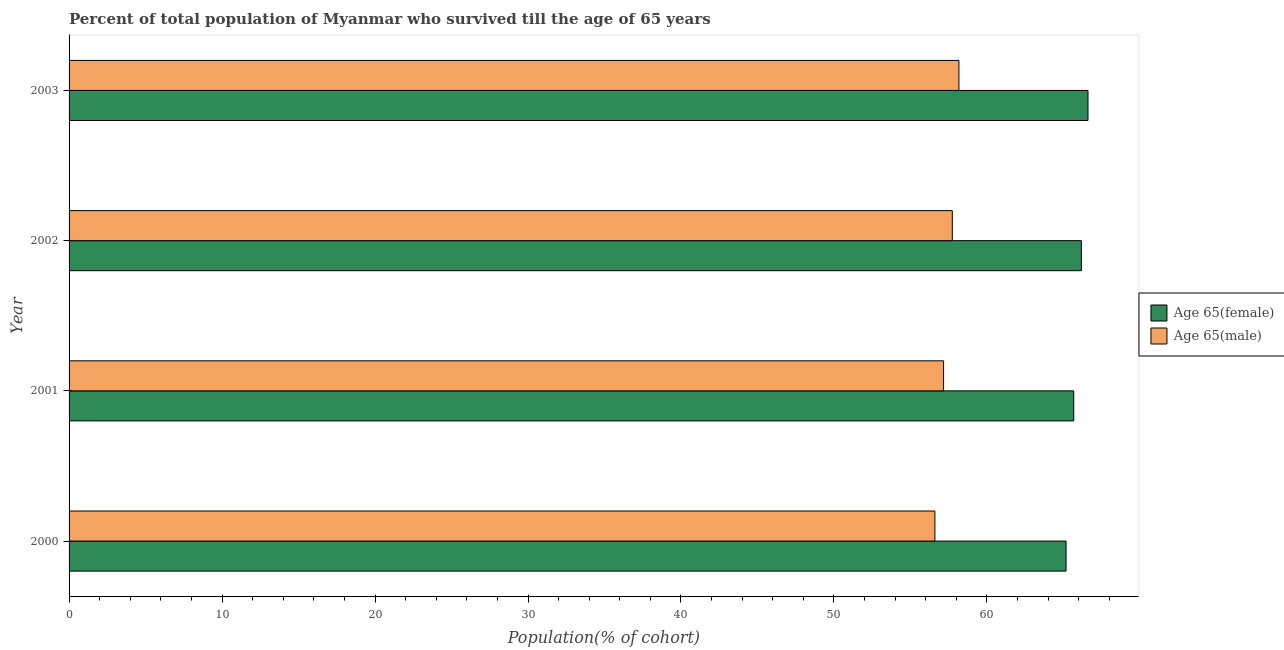Are the number of bars per tick equal to the number of legend labels?
Keep it short and to the point. Yes. In how many cases, is the number of bars for a given year not equal to the number of legend labels?
Ensure brevity in your answer.  0. What is the percentage of female population who survived till age of 65 in 2002?
Your answer should be compact. 66.17. Across all years, what is the maximum percentage of male population who survived till age of 65?
Offer a terse response. 58.17. Across all years, what is the minimum percentage of male population who survived till age of 65?
Your response must be concise. 56.6. In which year was the percentage of female population who survived till age of 65 maximum?
Offer a very short reply. 2003. What is the total percentage of male population who survived till age of 65 in the graph?
Provide a short and direct response. 229.67. What is the difference between the percentage of female population who survived till age of 65 in 2000 and that in 2003?
Your response must be concise. -1.43. What is the difference between the percentage of female population who survived till age of 65 in 2001 and the percentage of male population who survived till age of 65 in 2003?
Provide a short and direct response. 7.5. What is the average percentage of female population who survived till age of 65 per year?
Your answer should be compact. 65.91. In the year 2001, what is the difference between the percentage of female population who survived till age of 65 and percentage of male population who survived till age of 65?
Make the answer very short. 8.51. Is the difference between the percentage of female population who survived till age of 65 in 2000 and 2002 greater than the difference between the percentage of male population who survived till age of 65 in 2000 and 2002?
Keep it short and to the point. Yes. What is the difference between the highest and the second highest percentage of female population who survived till age of 65?
Your response must be concise. 0.43. What is the difference between the highest and the lowest percentage of female population who survived till age of 65?
Provide a succinct answer. 1.43. In how many years, is the percentage of male population who survived till age of 65 greater than the average percentage of male population who survived till age of 65 taken over all years?
Your answer should be compact. 2. What does the 2nd bar from the top in 2002 represents?
Provide a succinct answer. Age 65(female). What does the 2nd bar from the bottom in 2001 represents?
Offer a very short reply. Age 65(male). Are all the bars in the graph horizontal?
Provide a short and direct response. Yes. Are the values on the major ticks of X-axis written in scientific E-notation?
Make the answer very short. No. Does the graph contain grids?
Give a very brief answer. No. Where does the legend appear in the graph?
Offer a very short reply. Center right. How many legend labels are there?
Your response must be concise. 2. How are the legend labels stacked?
Your answer should be compact. Vertical. What is the title of the graph?
Provide a short and direct response. Percent of total population of Myanmar who survived till the age of 65 years. Does "Quasi money growth" appear as one of the legend labels in the graph?
Give a very brief answer. No. What is the label or title of the X-axis?
Ensure brevity in your answer.  Population(% of cohort). What is the Population(% of cohort) of Age 65(female) in 2000?
Your answer should be compact. 65.17. What is the Population(% of cohort) of Age 65(male) in 2000?
Provide a succinct answer. 56.6. What is the Population(% of cohort) of Age 65(female) in 2001?
Your answer should be compact. 65.67. What is the Population(% of cohort) of Age 65(male) in 2001?
Provide a succinct answer. 57.17. What is the Population(% of cohort) in Age 65(female) in 2002?
Your response must be concise. 66.17. What is the Population(% of cohort) of Age 65(male) in 2002?
Your answer should be very brief. 57.74. What is the Population(% of cohort) in Age 65(female) in 2003?
Your answer should be compact. 66.61. What is the Population(% of cohort) of Age 65(male) in 2003?
Your answer should be compact. 58.17. Across all years, what is the maximum Population(% of cohort) of Age 65(female)?
Offer a very short reply. 66.61. Across all years, what is the maximum Population(% of cohort) in Age 65(male)?
Your answer should be compact. 58.17. Across all years, what is the minimum Population(% of cohort) of Age 65(female)?
Keep it short and to the point. 65.17. Across all years, what is the minimum Population(% of cohort) in Age 65(male)?
Your response must be concise. 56.6. What is the total Population(% of cohort) of Age 65(female) in the graph?
Your answer should be very brief. 263.63. What is the total Population(% of cohort) of Age 65(male) in the graph?
Your response must be concise. 229.67. What is the difference between the Population(% of cohort) of Age 65(female) in 2000 and that in 2001?
Make the answer very short. -0.5. What is the difference between the Population(% of cohort) of Age 65(male) in 2000 and that in 2001?
Give a very brief answer. -0.57. What is the difference between the Population(% of cohort) in Age 65(female) in 2000 and that in 2002?
Ensure brevity in your answer.  -1. What is the difference between the Population(% of cohort) in Age 65(male) in 2000 and that in 2002?
Offer a very short reply. -1.14. What is the difference between the Population(% of cohort) in Age 65(female) in 2000 and that in 2003?
Your answer should be compact. -1.43. What is the difference between the Population(% of cohort) of Age 65(male) in 2000 and that in 2003?
Provide a short and direct response. -1.57. What is the difference between the Population(% of cohort) in Age 65(female) in 2001 and that in 2002?
Your answer should be compact. -0.5. What is the difference between the Population(% of cohort) in Age 65(male) in 2001 and that in 2002?
Offer a very short reply. -0.57. What is the difference between the Population(% of cohort) in Age 65(female) in 2001 and that in 2003?
Offer a terse response. -0.93. What is the difference between the Population(% of cohort) of Age 65(male) in 2001 and that in 2003?
Make the answer very short. -1. What is the difference between the Population(% of cohort) in Age 65(female) in 2002 and that in 2003?
Offer a terse response. -0.43. What is the difference between the Population(% of cohort) in Age 65(male) in 2002 and that in 2003?
Give a very brief answer. -0.43. What is the difference between the Population(% of cohort) in Age 65(female) in 2000 and the Population(% of cohort) in Age 65(male) in 2001?
Ensure brevity in your answer.  8.01. What is the difference between the Population(% of cohort) of Age 65(female) in 2000 and the Population(% of cohort) of Age 65(male) in 2002?
Give a very brief answer. 7.44. What is the difference between the Population(% of cohort) of Age 65(female) in 2000 and the Population(% of cohort) of Age 65(male) in 2003?
Provide a short and direct response. 7. What is the difference between the Population(% of cohort) in Age 65(female) in 2001 and the Population(% of cohort) in Age 65(male) in 2002?
Keep it short and to the point. 7.94. What is the difference between the Population(% of cohort) of Age 65(female) in 2001 and the Population(% of cohort) of Age 65(male) in 2003?
Make the answer very short. 7.5. What is the difference between the Population(% of cohort) of Age 65(female) in 2002 and the Population(% of cohort) of Age 65(male) in 2003?
Offer a terse response. 8.01. What is the average Population(% of cohort) of Age 65(female) per year?
Your answer should be very brief. 65.91. What is the average Population(% of cohort) in Age 65(male) per year?
Your answer should be compact. 57.42. In the year 2000, what is the difference between the Population(% of cohort) of Age 65(female) and Population(% of cohort) of Age 65(male)?
Provide a short and direct response. 8.57. In the year 2001, what is the difference between the Population(% of cohort) of Age 65(female) and Population(% of cohort) of Age 65(male)?
Your response must be concise. 8.51. In the year 2002, what is the difference between the Population(% of cohort) of Age 65(female) and Population(% of cohort) of Age 65(male)?
Provide a short and direct response. 8.44. In the year 2003, what is the difference between the Population(% of cohort) of Age 65(female) and Population(% of cohort) of Age 65(male)?
Keep it short and to the point. 8.44. What is the ratio of the Population(% of cohort) in Age 65(female) in 2000 to that in 2001?
Provide a short and direct response. 0.99. What is the ratio of the Population(% of cohort) of Age 65(male) in 2000 to that in 2001?
Your response must be concise. 0.99. What is the ratio of the Population(% of cohort) in Age 65(female) in 2000 to that in 2002?
Give a very brief answer. 0.98. What is the ratio of the Population(% of cohort) in Age 65(male) in 2000 to that in 2002?
Keep it short and to the point. 0.98. What is the ratio of the Population(% of cohort) in Age 65(female) in 2000 to that in 2003?
Provide a succinct answer. 0.98. What is the ratio of the Population(% of cohort) of Age 65(male) in 2001 to that in 2002?
Make the answer very short. 0.99. What is the ratio of the Population(% of cohort) in Age 65(female) in 2001 to that in 2003?
Provide a succinct answer. 0.99. What is the ratio of the Population(% of cohort) in Age 65(male) in 2001 to that in 2003?
Give a very brief answer. 0.98. What is the ratio of the Population(% of cohort) of Age 65(female) in 2002 to that in 2003?
Provide a short and direct response. 0.99. What is the ratio of the Population(% of cohort) in Age 65(male) in 2002 to that in 2003?
Your answer should be compact. 0.99. What is the difference between the highest and the second highest Population(% of cohort) in Age 65(female)?
Provide a short and direct response. 0.43. What is the difference between the highest and the second highest Population(% of cohort) in Age 65(male)?
Your answer should be very brief. 0.43. What is the difference between the highest and the lowest Population(% of cohort) of Age 65(female)?
Provide a short and direct response. 1.43. What is the difference between the highest and the lowest Population(% of cohort) in Age 65(male)?
Offer a terse response. 1.57. 